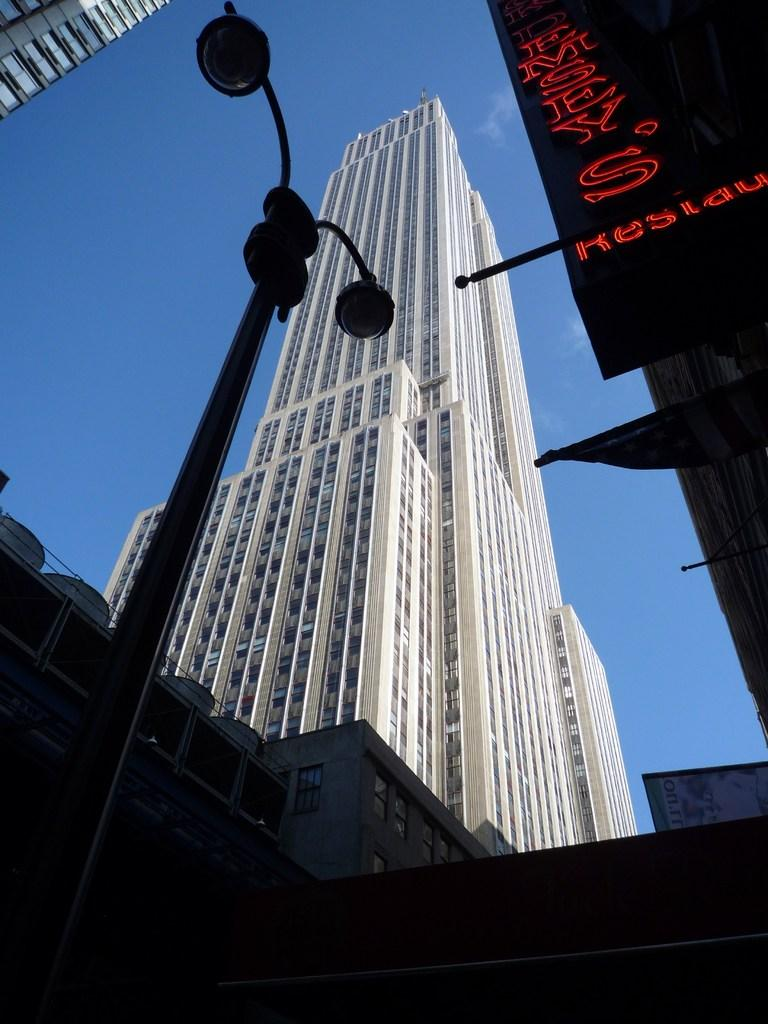What type of structures can be seen in the image? There are buildings in the image. Is there any additional information on the buildings? Yes, there is a banner with text hanging from one of the buildings. What can be seen on the pole in the image? There are two lights on a pole in the image. What part of the natural environment is visible in the image? The sky is visible in the image. What type of produce is being sold at the place in the image? There is no indication of a place selling produce in the image. 